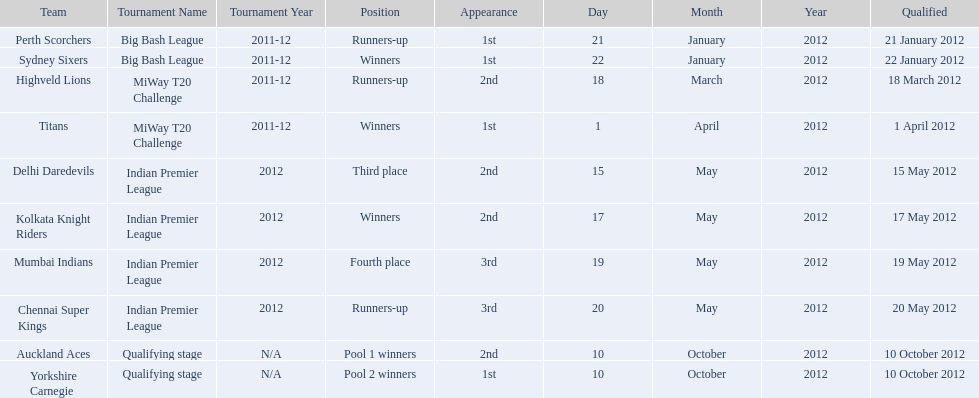Which game came in first in the 2012 indian premier league? Kolkata Knight Riders. 